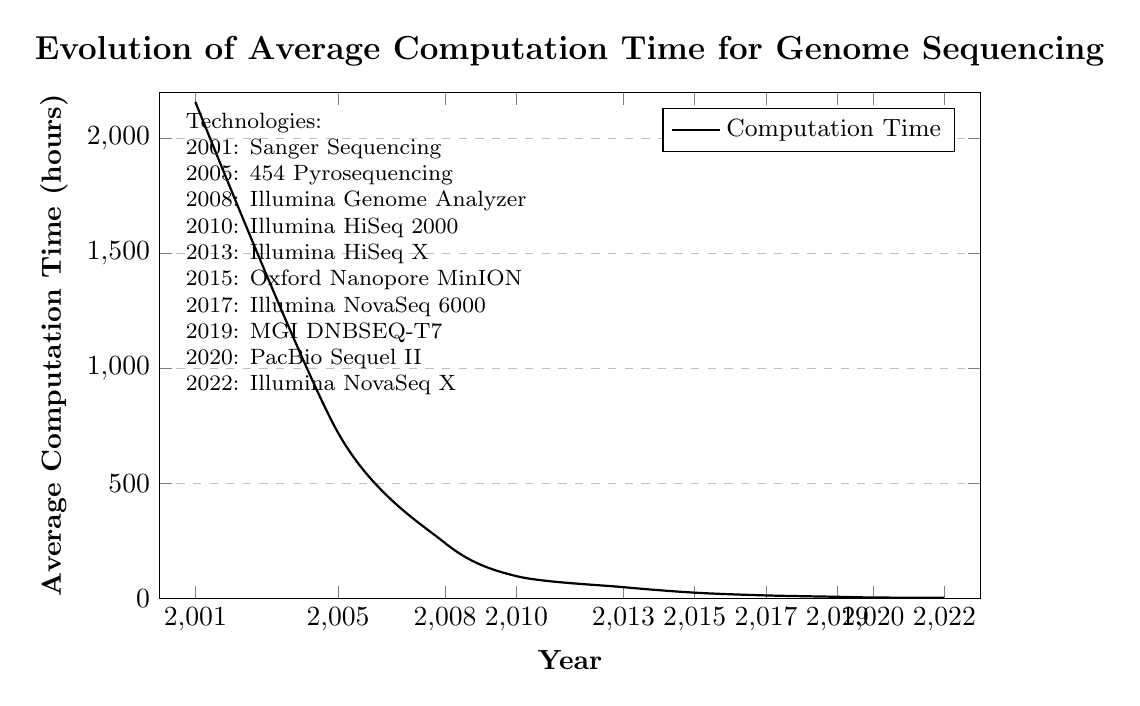What technology is used in the year 2008? The figure shows the label for 2008 marking it with Illumina Genome Analyzer technology.
Answer: Illumina Genome Analyzer How does the computation time in 2013 compare to that in 2008? The computation time in 2013 is 48 hours, while in 2008 it is 240 hours. 48 hours is less than 240 hours.
Answer: Less What is the overall trend shown in the plot? Observing the trend from the plot, the average computation time decreases consistently as years advance from 2001 to 2022.
Answer: Decreasing What is the difference in computation time between 2017 and 2020? The computation time in 2017 is 12 hours, and in 2020 it is 3 hours. The difference is 12 - 3 = 9 hours.
Answer: 9 hours Which year showed the highest reduction in computation time compared to the previous data point? Comparing the computation times of each data point, the reduction from 2001 (2160 hours) to 2005 (720 hours) is the highest with a difference of 2160 - 720 = 1440 hours.
Answer: 2005 What was the computation time using Oxford Nanopore MinION technology? The plot indicates that the Oxford Nanopore MinION technology was used in 2015 and had a computation time of 24 hours.
Answer: 24 hours What is the computation time for PacBio Sequel II, and in which year was it used? PacBio Sequel II was used in 2020 and had a computation time of 3 hours.
Answer: 3 hours, 2020 By how much did the computation time decrease from 2019 to 2022? The computation time in 2019 is 6 hours and in 2022 is 1.5 hours. The decrease is 6 - 1.5 = 4.5 hours.
Answer: 4.5 hours How many types of sequencing technologies are represented in the plot? By counting the labels in the figure’s legend, a total of 10 different sequencing technologies are represented.
Answer: 10 What was the average computation time in the period 2001-2010? The computation times are 2160, 720, 240, and 96 for the years 2001, 2005, 2008, and 2010, respectively. Their sum is 2160 + 720 + 240 + 96 = 3216. The average over 4 years is 3216 / 4 = 804 hours.
Answer: 804 hours 